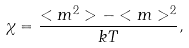<formula> <loc_0><loc_0><loc_500><loc_500>\chi = \frac { < m ^ { 2 } > - < m > ^ { 2 } } { k T } ,</formula> 